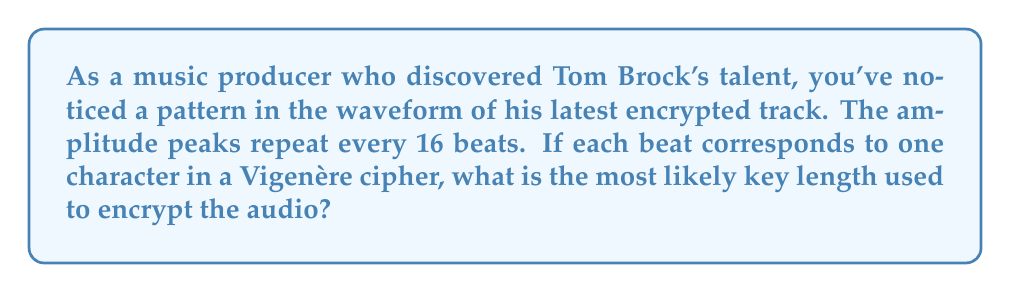Teach me how to tackle this problem. To determine the key length in a Vigenère cipher using audio waveform patterns, we follow these steps:

1. Identify the repeating pattern in the waveform:
   In this case, the amplitude peaks repeat every 16 beats.

2. Understand the relationship between beats and characters:
   Each beat corresponds to one character in the Vigenère cipher.

3. Analyze the pattern length:
   The repetition of peaks every 16 beats suggests a pattern in the ciphertext that repeats every 16 characters.

4. Relate pattern length to key length:
   In a Vigenère cipher, the ciphertext pattern length is typically equal to the key length. This is because the key is repeated to match the length of the plaintext, creating a cyclic pattern in the ciphertext.

5. Conclude the most likely key length:
   Given that the pattern repeats every 16 beats (characters), the most likely key length is also 16.

The key length in a Vigenère cipher determines the strength of the encryption. A longer key generally provides stronger encryption, as it increases the complexity of the cipher and makes it more resistant to frequency analysis attacks.
Answer: 16 